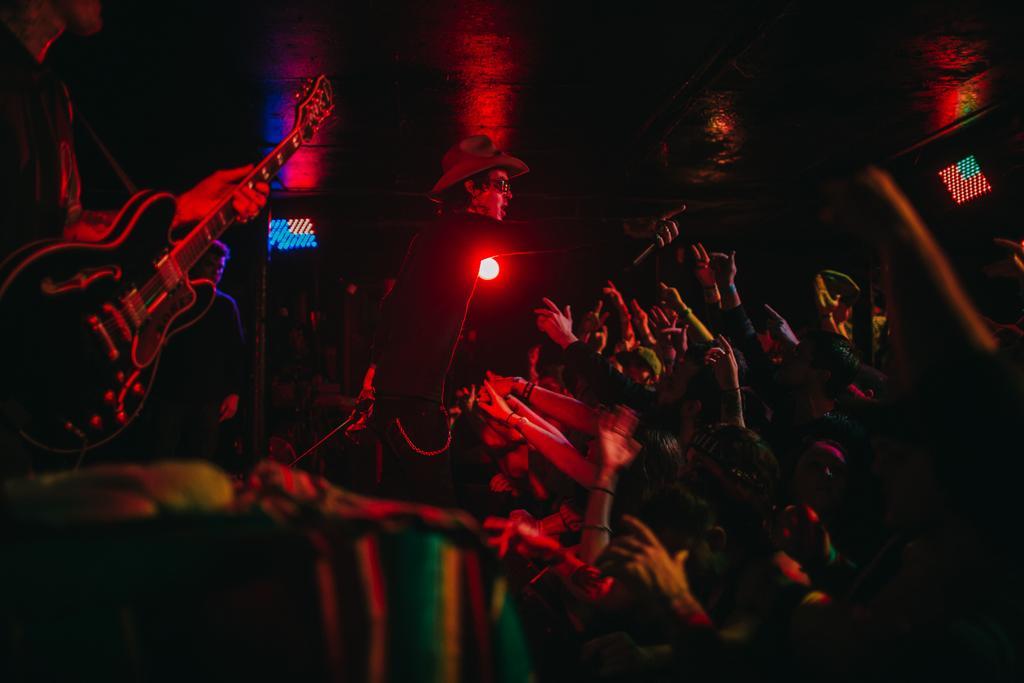Describe this image in one or two sentences. This picture is clicked in a musical concert. On the left top of the picture, we see man wearing guitar man holding guitar and playing it and in front of them, we see many people enjoying the music. 